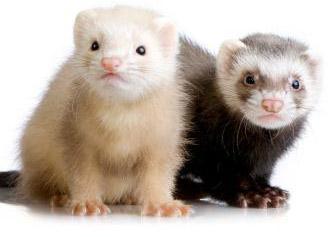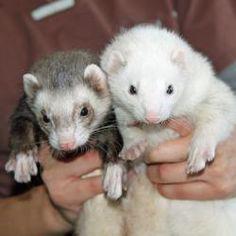The first image is the image on the left, the second image is the image on the right. Considering the images on both sides, is "Two ferrets with the same fur color pattern are wearing clothes." valid? Answer yes or no. No. The first image is the image on the left, the second image is the image on the right. Examine the images to the left and right. Is the description "Each image contains two ferrets, and one image shows hands holding up unclothed ferrets." accurate? Answer yes or no. Yes. 